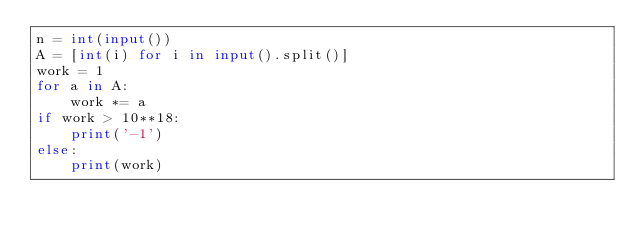Convert code to text. <code><loc_0><loc_0><loc_500><loc_500><_Python_>n = int(input())
A = [int(i) for i in input().split()]
work = 1
for a in A:
    work *= a
if work > 10**18:
    print('-1')
else:
    print(work)</code> 